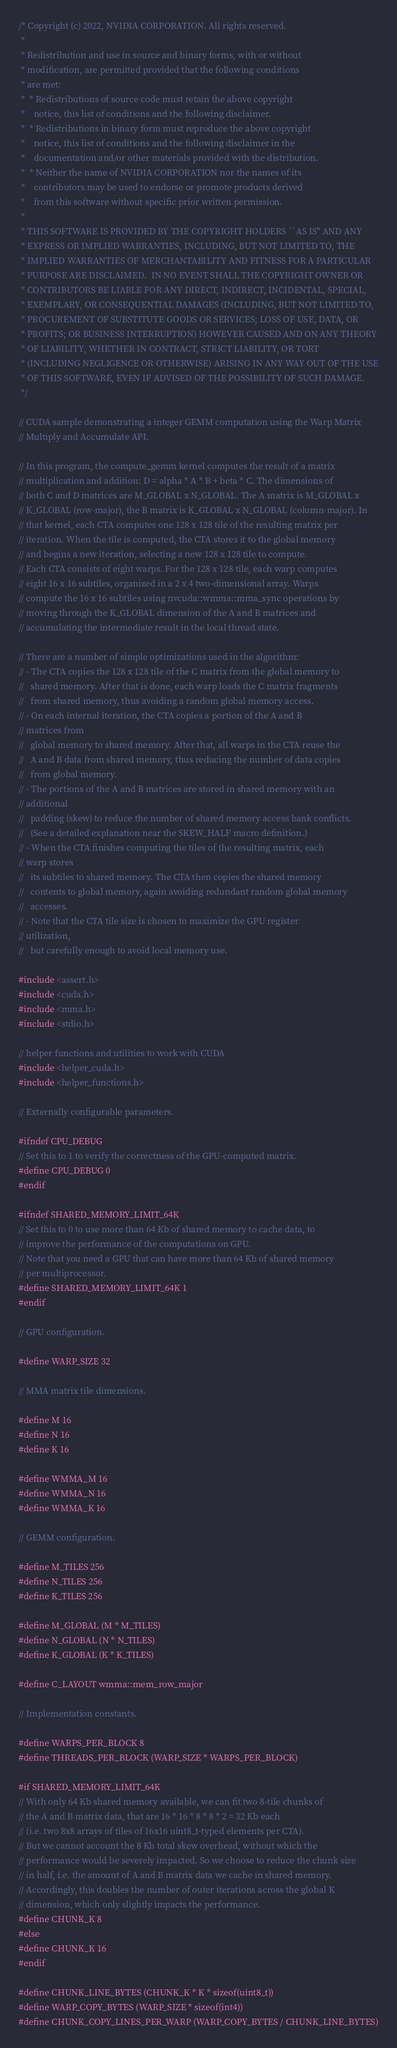Convert code to text. <code><loc_0><loc_0><loc_500><loc_500><_Cuda_>/* Copyright (c) 2022, NVIDIA CORPORATION. All rights reserved.
 *
 * Redistribution and use in source and binary forms, with or without
 * modification, are permitted provided that the following conditions
 * are met:
 *  * Redistributions of source code must retain the above copyright
 *    notice, this list of conditions and the following disclaimer.
 *  * Redistributions in binary form must reproduce the above copyright
 *    notice, this list of conditions and the following disclaimer in the
 *    documentation and/or other materials provided with the distribution.
 *  * Neither the name of NVIDIA CORPORATION nor the names of its
 *    contributors may be used to endorse or promote products derived
 *    from this software without specific prior written permission.
 *
 * THIS SOFTWARE IS PROVIDED BY THE COPYRIGHT HOLDERS ``AS IS'' AND ANY
 * EXPRESS OR IMPLIED WARRANTIES, INCLUDING, BUT NOT LIMITED TO, THE
 * IMPLIED WARRANTIES OF MERCHANTABILITY AND FITNESS FOR A PARTICULAR
 * PURPOSE ARE DISCLAIMED.  IN NO EVENT SHALL THE COPYRIGHT OWNER OR
 * CONTRIBUTORS BE LIABLE FOR ANY DIRECT, INDIRECT, INCIDENTAL, SPECIAL,
 * EXEMPLARY, OR CONSEQUENTIAL DAMAGES (INCLUDING, BUT NOT LIMITED TO,
 * PROCUREMENT OF SUBSTITUTE GOODS OR SERVICES; LOSS OF USE, DATA, OR
 * PROFITS; OR BUSINESS INTERRUPTION) HOWEVER CAUSED AND ON ANY THEORY
 * OF LIABILITY, WHETHER IN CONTRACT, STRICT LIABILITY, OR TORT
 * (INCLUDING NEGLIGENCE OR OTHERWISE) ARISING IN ANY WAY OUT OF THE USE
 * OF THIS SOFTWARE, EVEN IF ADVISED OF THE POSSIBILITY OF SUCH DAMAGE.
 */

// CUDA sample demonstrating a integer GEMM computation using the Warp Matrix
// Multiply and Accumulate API.

// In this program, the compute_gemm kernel computes the result of a matrix
// multiplication and addition: D = alpha * A * B + beta * C. The dimensions of
// both C and D matrices are M_GLOBAL x N_GLOBAL. The A matrix is M_GLOBAL x
// K_GLOBAL (row-major), the B matrix is K_GLOBAL x N_GLOBAL (column-major). In
// that kernel, each CTA computes one 128 x 128 tile of the resulting matrix per
// iteration. When the tile is computed, the CTA stores it to the global memory
// and begins a new iteration, selecting a new 128 x 128 tile to compute.
// Each CTA consists of eight warps. For the 128 x 128 tile, each warp computes
// eight 16 x 16 subtiles, organized in a 2 x 4 two-dimensional array. Warps
// compute the 16 x 16 subtiles using nvcuda::wmma::mma_sync operations by
// moving through the K_GLOBAL dimension of the A and B matrices and
// accumulating the intermediate result in the local thread state.

// There are a number of simple optimizations used in the algorithm:
// - The CTA copies the 128 x 128 tile of the C matrix from the global memory to
//   shared memory. After that is done, each warp loads the C matrix fragments
//   from shared memory, thus avoiding a random global memory access.
// - On each internal iteration, the CTA copies a portion of the A and B
// matrices from
//   global memory to shared memory. After that, all warps in the CTA reuse the
//   A and B data from shared memory, thus reducing the number of data copies
//   from global memory.
// - The portions of the A and B matrices are stored in shared memory with an
// additional
//   padding (skew) to reduce the number of shared memory access bank conflicts.
//   (See a detailed explanation near the SKEW_HALF macro definition.)
// - When the CTA finishes computing the tiles of the resulting matrix, each
// warp stores
//   its subtiles to shared memory. The CTA then copies the shared memory
//   contents to global memory, again avoiding redundant random global memory
//   accesses.
// - Note that the CTA tile size is chosen to maximize the GPU register
// utilization,
//   but carefully enough to avoid local memory use.

#include <assert.h>
#include <cuda.h>
#include <mma.h>
#include <stdio.h>

// helper functions and utilities to work with CUDA
#include <helper_cuda.h>
#include <helper_functions.h>

// Externally configurable parameters.

#ifndef CPU_DEBUG
// Set this to 1 to verify the correctness of the GPU-computed matrix.
#define CPU_DEBUG 0
#endif

#ifndef SHARED_MEMORY_LIMIT_64K
// Set this to 0 to use more than 64 Kb of shared memory to cache data, to
// improve the performance of the computations on GPU.
// Note that you need a GPU that can have more than 64 Kb of shared memory
// per multiprocessor.
#define SHARED_MEMORY_LIMIT_64K 1
#endif

// GPU configuration.

#define WARP_SIZE 32

// MMA matrix tile dimensions.

#define M 16
#define N 16
#define K 16

#define WMMA_M 16
#define WMMA_N 16
#define WMMA_K 16

// GEMM configuration.

#define M_TILES 256
#define N_TILES 256
#define K_TILES 256

#define M_GLOBAL (M * M_TILES)
#define N_GLOBAL (N * N_TILES)
#define K_GLOBAL (K * K_TILES)

#define C_LAYOUT wmma::mem_row_major

// Implementation constants.

#define WARPS_PER_BLOCK 8
#define THREADS_PER_BLOCK (WARP_SIZE * WARPS_PER_BLOCK)

#if SHARED_MEMORY_LIMIT_64K
// With only 64 Kb shared memory available, we can fit two 8-tile chunks of
// the A and B matrix data, that are 16 * 16 * 8 * 8 * 2 = 32 Kb each
// (i.e. two 8x8 arrays of tiles of 16x16 uint8_t-typed elements per CTA).
// But we cannot account the 8 Kb total skew overhead, without which the
// performance would be severely impacted. So we choose to reduce the chunk size
// in half, i.e. the amount of A and B matrix data we cache in shared memory.
// Accordingly, this doubles the number of outer iterations across the global K
// dimension, which only slightly impacts the performance.
#define CHUNK_K 8
#else
#define CHUNK_K 16
#endif

#define CHUNK_LINE_BYTES (CHUNK_K * K * sizeof(uint8_t))
#define WARP_COPY_BYTES (WARP_SIZE * sizeof(int4))
#define CHUNK_COPY_LINES_PER_WARP (WARP_COPY_BYTES / CHUNK_LINE_BYTES)</code> 